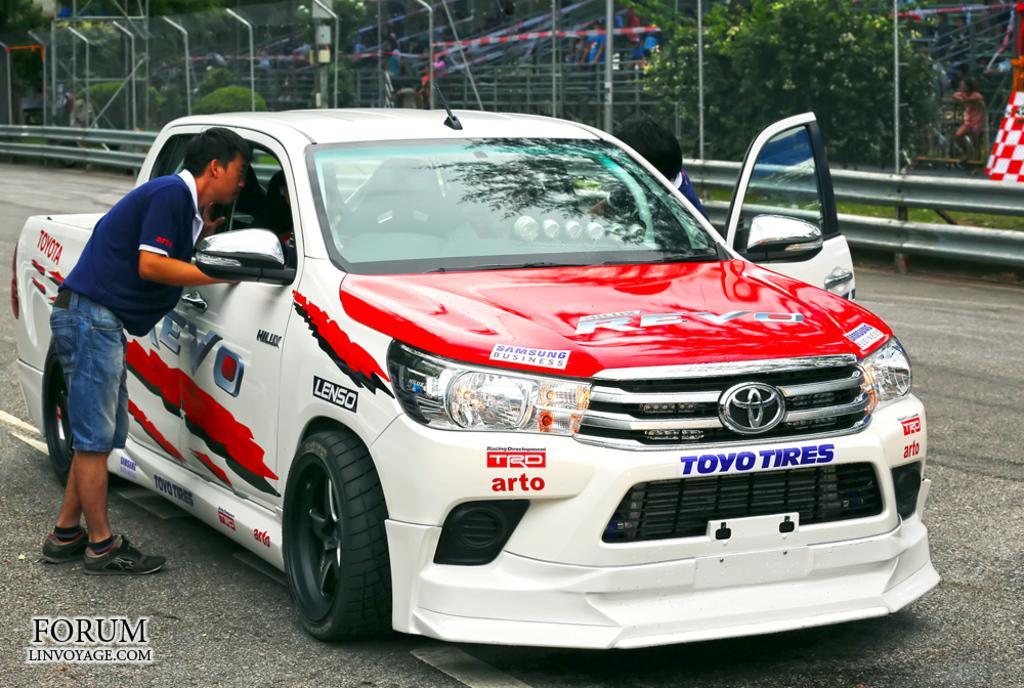Could you give a brief overview of what you see in this image? In this image I see a car which is of white, red and black in color and I see few words on it and I see a logo over here and I see 2 persons near to it and I see the road. In the background I see the fencing, trees and few people and I see the watermark over here. 